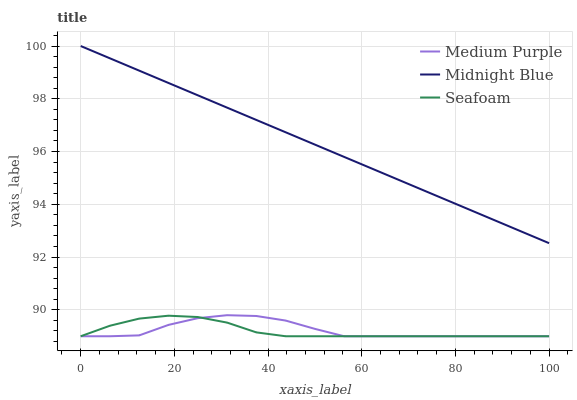Does Midnight Blue have the minimum area under the curve?
Answer yes or no. No. Does Seafoam have the maximum area under the curve?
Answer yes or no. No. Is Seafoam the smoothest?
Answer yes or no. No. Is Seafoam the roughest?
Answer yes or no. No. Does Midnight Blue have the lowest value?
Answer yes or no. No. Does Seafoam have the highest value?
Answer yes or no. No. Is Seafoam less than Midnight Blue?
Answer yes or no. Yes. Is Midnight Blue greater than Seafoam?
Answer yes or no. Yes. Does Seafoam intersect Midnight Blue?
Answer yes or no. No. 